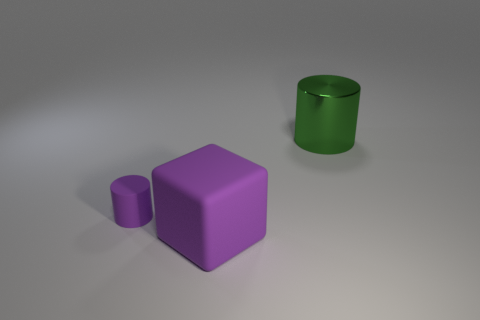There is a big cube; is its color the same as the cylinder in front of the green metal object? Yes, the big cube and the cylinder share the same color, which is purple. 